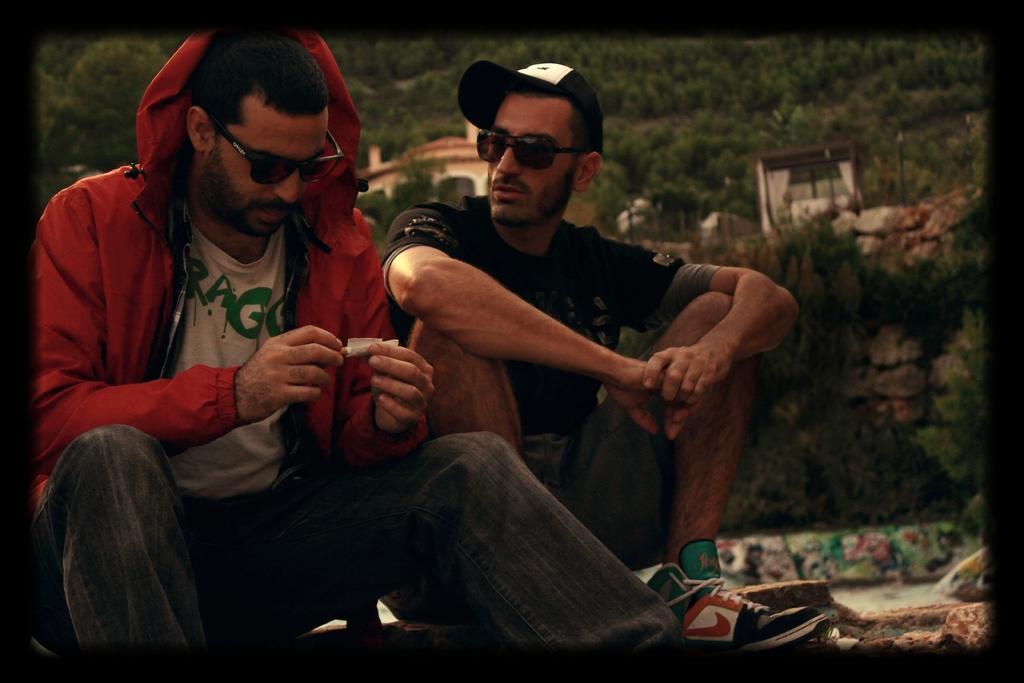How would you summarize this image in a sentence or two? In the center of the image we can see two persons are sitting and they are wearing glasses. Among them, we can see one person is holding some object and he is wearing a jacket and the other person is wearing a cap. In the background, we can see trees, buildings, stones and a few other objects. And we can see the black color border around the image. 